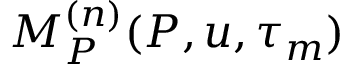Convert formula to latex. <formula><loc_0><loc_0><loc_500><loc_500>M _ { P } ^ { ( n ) } ( P , u , \tau _ { m } )</formula> 